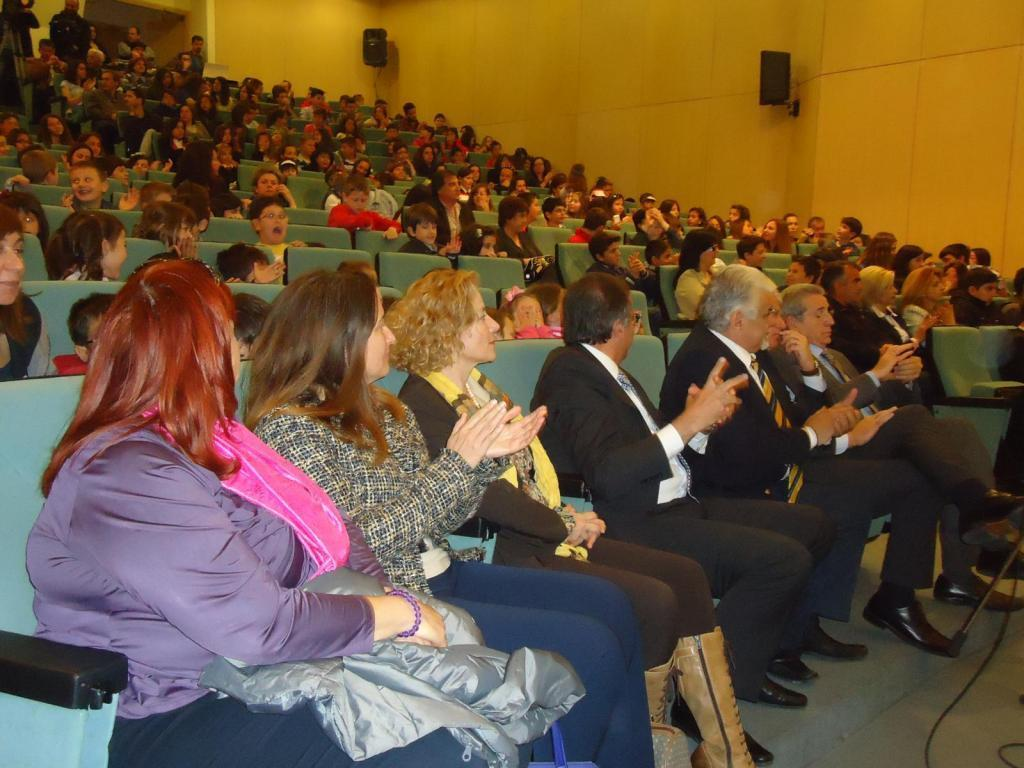What are the people in the image sitting on? There are people sitting on blue chairs in the image. What are the people in the background of the image doing? There are people standing in the background of the image. What can be seen on the wall in the background of the image? There are speaker boxes fixed to the wall in the background of the image. What type of sign is hanging from the sock in the image? There is no sign or sock present in the image. 